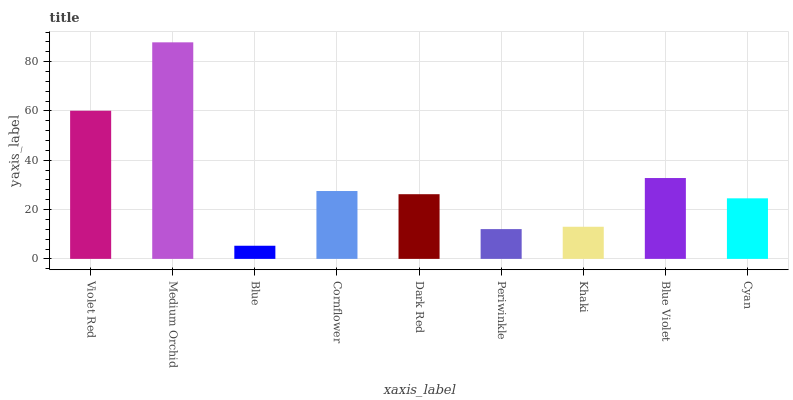Is Blue the minimum?
Answer yes or no. Yes. Is Medium Orchid the maximum?
Answer yes or no. Yes. Is Medium Orchid the minimum?
Answer yes or no. No. Is Blue the maximum?
Answer yes or no. No. Is Medium Orchid greater than Blue?
Answer yes or no. Yes. Is Blue less than Medium Orchid?
Answer yes or no. Yes. Is Blue greater than Medium Orchid?
Answer yes or no. No. Is Medium Orchid less than Blue?
Answer yes or no. No. Is Dark Red the high median?
Answer yes or no. Yes. Is Dark Red the low median?
Answer yes or no. Yes. Is Medium Orchid the high median?
Answer yes or no. No. Is Khaki the low median?
Answer yes or no. No. 